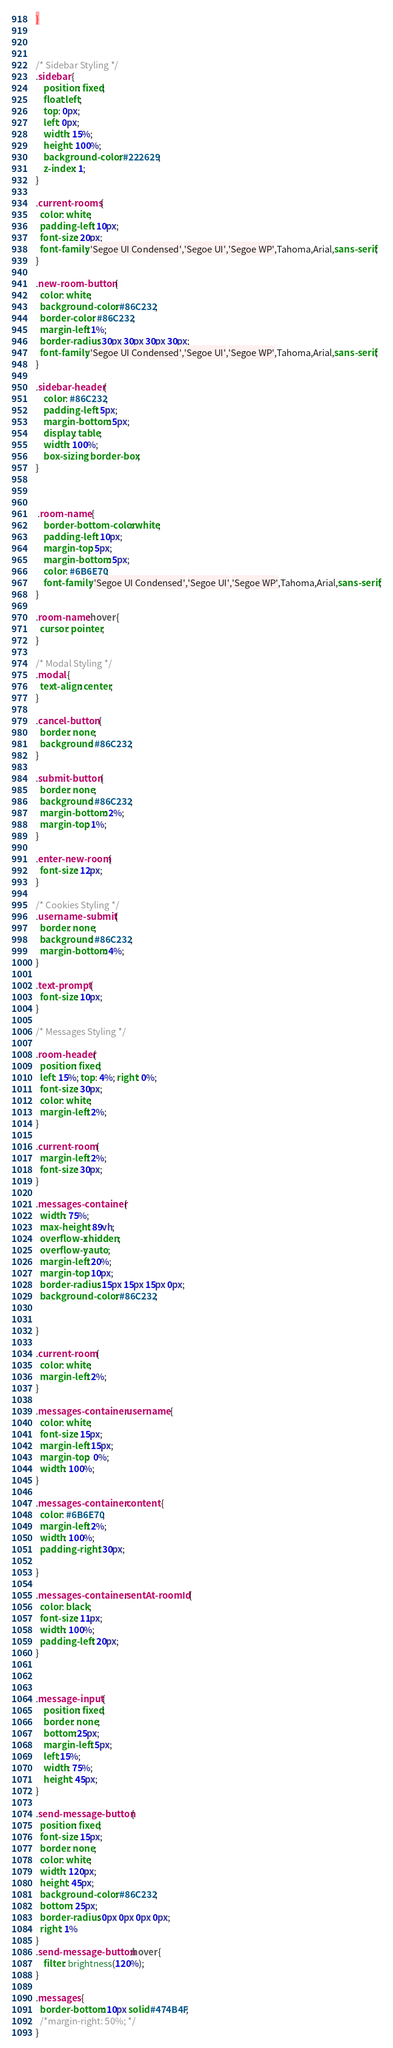<code> <loc_0><loc_0><loc_500><loc_500><_CSS_>}



/* Sidebar Styling */
.sidebar {
    position: fixed;
    float:left;
    top: 0px;
    left: 0px;
    width: 15%;
    height: 100%;
    background-color: #222629;
    z-index: 1;
}

.current-rooms {
  color: white;
  padding-left: 10px;
  font-size: 20px;
  font-family: 'Segoe UI Condensed','Segoe UI','Segoe WP',Tahoma,Arial,sans-serif;
}

.new-room-button {
  color: white;
  background-color: #86C232;
  border-color: #86C232;
  margin-left: 1%;
  border-radius: 30px 30px 30px 30px;
  font-family: 'Segoe UI Condensed','Segoe UI','Segoe WP',Tahoma,Arial,sans-serif;
}

.sidebar-header {
    color: #86C232;
    padding-left: 5px;
    margin-bottom: 5px;
    display: table;
    width: 100%;
    box-sizing: border-box;
}



 .room-name {
    border-bottom-color: white;
    padding-left: 10px;
    margin-top: 5px;
    margin-bottom: 5px;
    color: #6B6E70;
    font-family: 'Segoe UI Condensed','Segoe UI','Segoe WP',Tahoma,Arial,sans-serif;
}

.room-name:hover {
  cursor: pointer;
}

/* Modal Styling */
.modal {
  text-align: center;
}

.cancel-button {
  border: none;
  background: #86C232;
}

.submit-button {
  border: none;
  background: #86C232;
  margin-bottom: 2%;
  margin-top: 1%;
}

.enter-new-room {
  font-size: 12px;
}

/* Cookies Styling */
.username-submit {
  border: none;
  background: #86C232;
  margin-bottom: 4%;
}

.text-prompt {
  font-size: 10px;
}

/* Messages Styling */

.room-header{
  position: fixed;
  left: 15%; top: 4%; right: 0%;
  font-size: 30px;
  color: white;
  margin-left: 2%;
}

.current-room {
  margin-left: 2%;
  font-size: 30px;
}

.messages-container {
  width: 75%;
  max-height: 89vh;
  overflow-x: hidden;
  overflow-y: auto;
  margin-left: 20%;
  margin-top: 10px;
  border-radius: 15px 15px 15px 0px;
  background-color: #86C232;


}

.current-room {
  color: white;
  margin-left: 2%;
}

.messages-container .username {
  color: white;
  font-size: 15px;
  margin-left: 15px;
  margin-top:  0%;
  width: 100%;
}

.messages-container .content {
  color: #6B6E70;
  margin-left: 2%;
  width: 100%;
  padding-right: 30px;

}

.messages-container .sentAt-roomId {
  color: black;
  font-size: 11px;
  width: 100%;
  padding-left: 20px;
}



.message-input {
    position: fixed;
    border: none;
    bottom:25px;
    margin-left: 5px;
    left:15%;
    width: 75%;
    height: 45px;
}

.send-message-button {
  position: fixed;
  font-size: 15px;
  border: none;
  color: white;
  width: 120px;
  height: 45px;
  background-color: #86C232;
  bottom: 25px;
  border-radius: 0px 0px 0px 0px;
  right: 1%
}
.send-message-button:hover {
    filter: brightness(120%);
}

.messages {
  border-bottom: 10px solid #474B4F;
  /*margin-right: 50%; */
}
</code> 